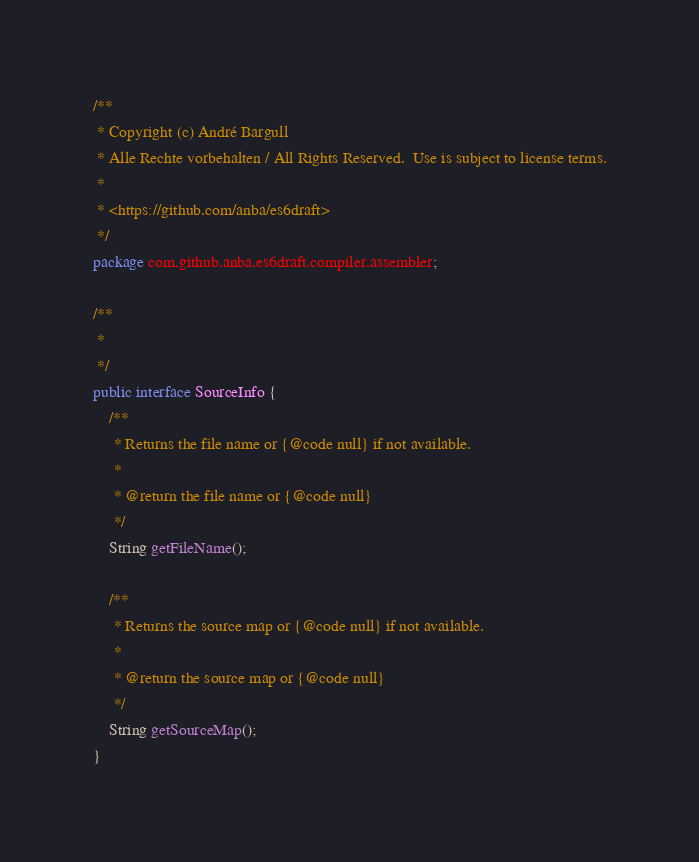<code> <loc_0><loc_0><loc_500><loc_500><_Java_>/**
 * Copyright (c) André Bargull
 * Alle Rechte vorbehalten / All Rights Reserved.  Use is subject to license terms.
 *
 * <https://github.com/anba/es6draft>
 */
package com.github.anba.es6draft.compiler.assembler;

/** 
 *
 */
public interface SourceInfo {
    /**
     * Returns the file name or {@code null} if not available.
     * 
     * @return the file name or {@code null}
     */
    String getFileName();

    /**
     * Returns the source map or {@code null} if not available.
     * 
     * @return the source map or {@code null}
     */
    String getSourceMap();
}
</code> 